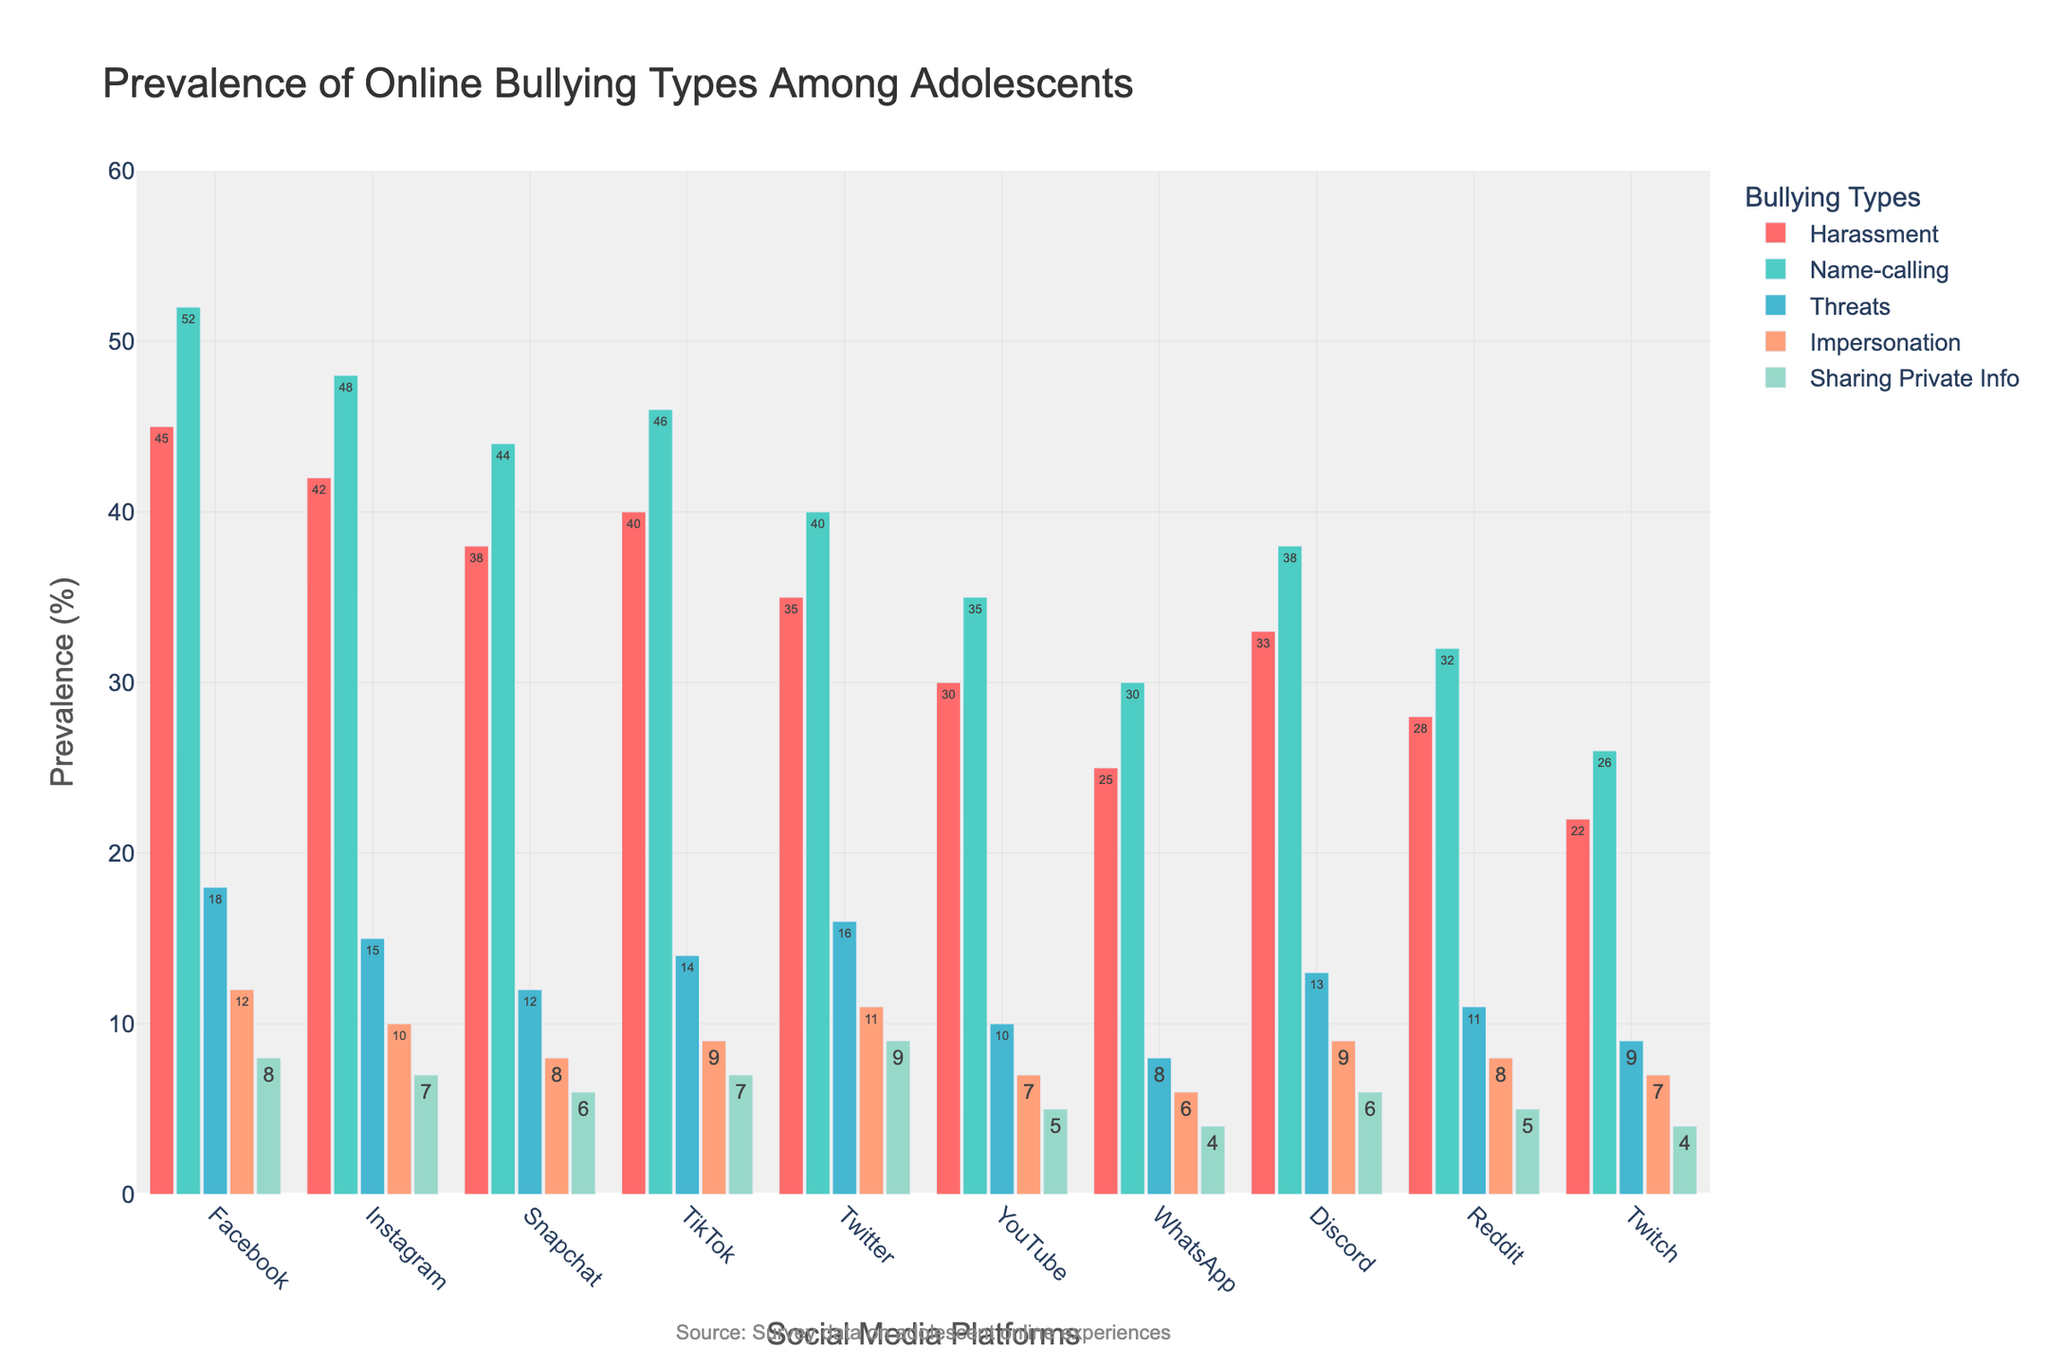What platform has the highest prevalence of name-calling? To find the platform with the highest prevalence of name-calling, look for the tallest bar among the name-calling bars. Facebook has the tallest bar in the name-calling category.
Answer: Facebook Which bullying type is most prevalent on Reddit? To determine the most prevalent bullying type on Reddit, compare the heights of the bars for each bullying type on the Reddit row. Name-calling has the tallest bar on Reddit.
Answer: Name-calling Compare harassment prevalence between Facebook and Twitter. Which platform has higher prevalence and by how much? To compare harassment prevalence, look at the harassment bars for Facebook and Twitter. Facebook has a prevalence of 45%, and Twitter has 35%. The difference is 45% - 35% = 10%.
Answer: Facebook has higher prevalence by 10% What is the total prevalence of impersonation across all platforms? To find the total prevalence of impersonation, sum the values of the impersonation bars for each platform: 12 + 10 + 8 + 9 + 11 + 7 + 6 + 9 + 8 + 7 = 87%.
Answer: 87% Which platform has the lowest prevalence of threats? To find the platform with the lowest prevalence of threats, look for the shortest bar in the threats category. Twitch has the shortest bar among the threats bars.
Answer: Twitch On which platform is the prevalence of harassment closest to 40%? To find the platform where harassment prevalence is closest to 40%, compare each platform's harassment bar to 40%. TikTok has a harassment prevalence of 40%, which matches exactly.
Answer: TikTok What is the average prevalence of sharing private info across all platforms? To find the average prevalence of sharing private info, sum the values and divide by the number of platforms: (8 + 7 + 6 + 7 + 9 + 5 + 4 + 6 + 5 + 4) / 10 = 6.1%.
Answer: 6.1% Compare the sum of name-calling and threats on Facebook and Instagram. Which platform has a higher combined prevalence and what is the difference? To compare the sums, add the values for each bullying type for both platforms. For Facebook: 52 + 18 = 70%, and for Instagram: 48 + 15 = 63%. The difference is 70% - 63% = 7%.
Answer: Facebook has higher combined prevalence by 7% Which platform shows the highest variability in the prevalence of different bullying types? To find the platform with the highest variability, visually compare the range of heights of the bars within each platform. Facebook shows the highest variability with bars ranging from 8% to 52%.
Answer: Facebook What platform has the second-highest prevalence of impersonation? To determine the platform with the second-highest prevalence of impersonation, look for the second tallest bar in the impersonation category. Twitter has the second highest prevalence with 11%, after Facebook's 12%.
Answer: Twitter 